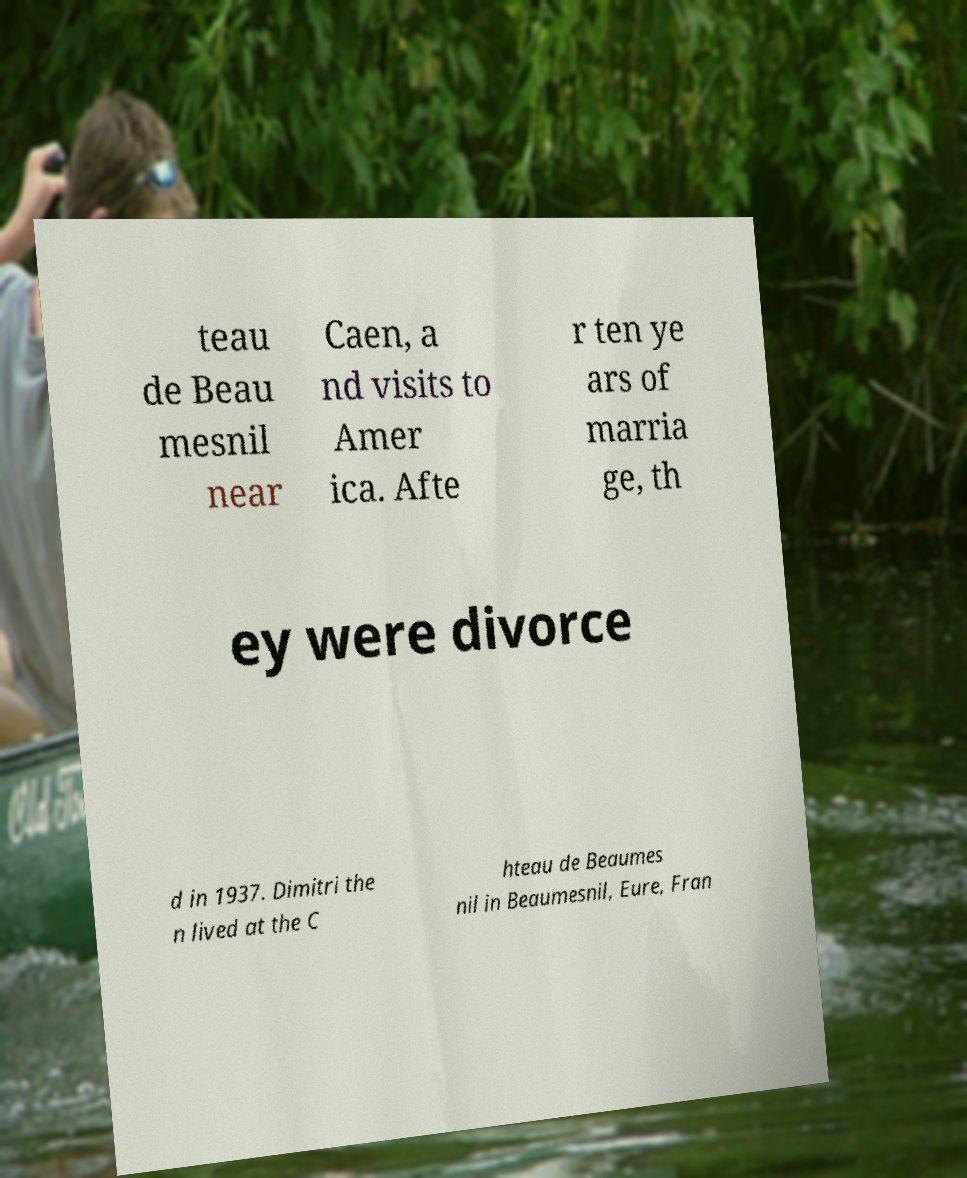Could you extract and type out the text from this image? teau de Beau mesnil near Caen, a nd visits to Amer ica. Afte r ten ye ars of marria ge, th ey were divorce d in 1937. Dimitri the n lived at the C hteau de Beaumes nil in Beaumesnil, Eure, Fran 